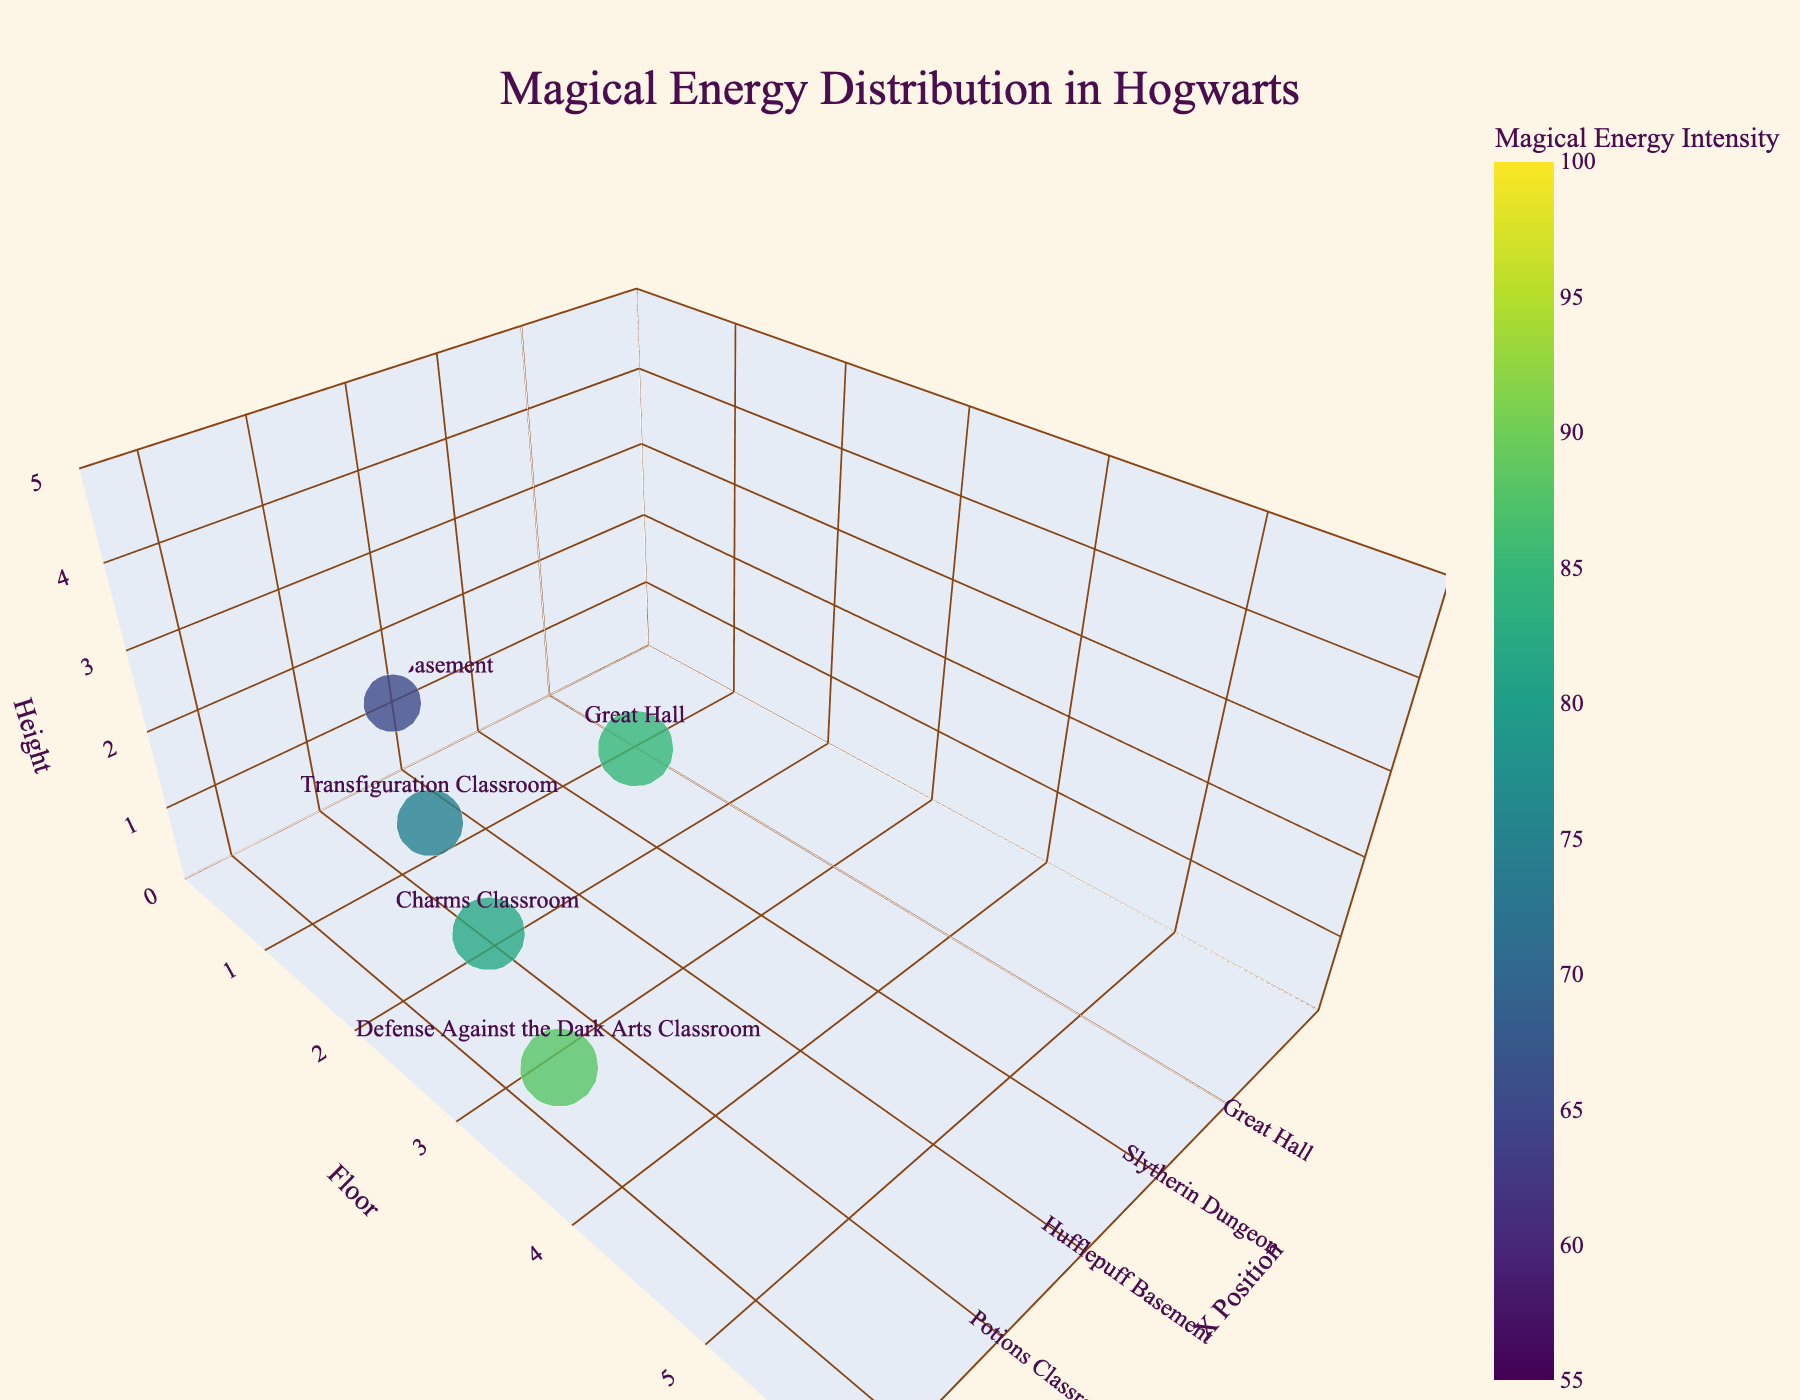What's the title of the plot? The title is positioned at the top center of the plot.
Answer: Magical Energy Distribution in Hogwarts How many rooms are displayed in the plot? The number of data points (markers) in the figure corresponds to the number of rooms.
Answer: 20 Which room has the highest magical energy intensity? By looking at the color code and intensity labels, the Room of Requirement has the highest intensity of 100.
Answer: Room of Requirement Which floor does the Headmaster's Office belong to? The floor is identified by looking at the y-coordinate for the Headmaster's Office, which is labeled 4.
Answer: Floor 4 What is the magical energy intensity of the Astronomy Tower? The marker for the Astronomy Tower shows an intensity value of 90.
Answer: 90 Which room has a higher intensity, Charms Classroom or Potions Classroom? By comparing the markers' intensities, Charms Classroom is 82 and Potions Classroom is 80.
Answer: Charms Classroom What is the difference in magical energy intensity between the Gryffindor Tower and the Hufflepuff Basement? Gryffindor Tower has an intensity of 72, and Hufflepuff Basement has an intensity of 65. The difference is 72 - 65.
Answer: 7 What is the average magical energy intensity of the classrooms only? The classrooms are Potions (80), Transfiguration (75), Charms (82), Defense Against the Dark Arts (88), and Divination (73). The sum is 398, and there are 5 classrooms. The average is 398/5.
Answer: 79.6 Which rooms are located on Floor 3? By looking at the y-coordinate value 3, it's Gryffindor Tower and Room of Requirement.
Answer: Gryffindor Tower, Room of Requirement Between the Great Hall and the Forbidden Forest, which has a lower magical energy intensity? The Great Hall has an intensity of 85, and the Forbidden Forest has 55. 55 is lower.
Answer: Forbidden Forest 